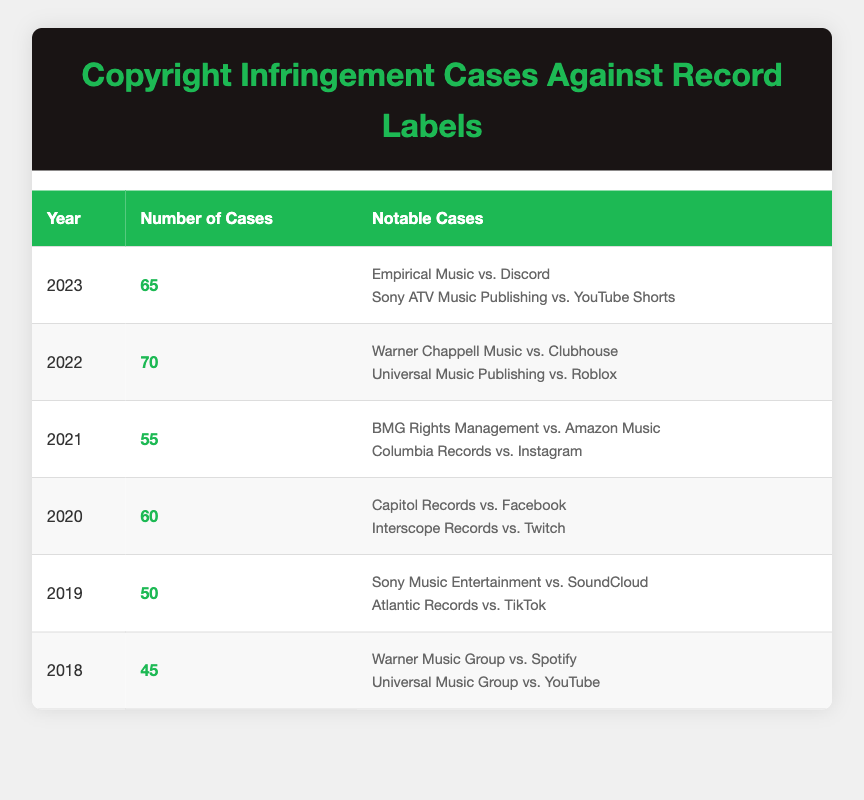What was the year with the highest number of copyright infringement cases? By reviewing the 'Number of Cases' column, the highest number is 70, which occurred in 2022.
Answer: 2022 How many cases were filed in 2019? Directly from the table, the number of cases filed in 2019 is 50.
Answer: 50 What is the average number of copyright infringement cases from 2018 to 2023? To find the average, sum the number of cases (45 + 50 + 60 + 55 + 70 + 65 = 345) and divide by the number of years (6). 345 / 6 = 57.5
Answer: 57.5 Was there an increase in the number of cases from 2020 to 2021? In 2020, there were 60 cases, and in 2021, there were 55 cases, showing a decrease of 5 cases.
Answer: No Which year had notable cases involving social media platforms? The years with notable cases involving social media platforms are 2020 (Facebook, Twitch), 2021 (Amazon Music, Instagram), 2022 (Clubhouse, Roblox), and 2023 (Discord, YouTube Shorts).
Answer: 2020, 2021, 2022, 2023 How many more cases were filed in 2022 compared to 2018? The number of cases in 2022 was 70 and in 2018 was 45. The difference is 70 - 45 = 25.
Answer: 25 Was the total number of cases filed in 2023 less than in 2022? In 2022, there were 70 cases, and in 2023, there were 65 cases, confirming that 65 is less than 70.
Answer: Yes What percentage of the total cases from 2018 to 2023 occurred in 2022? The total number of cases is 345. For 2022, the calculation is (70 / 345) * 100, which is approximately 20.29%.
Answer: 20.29% 